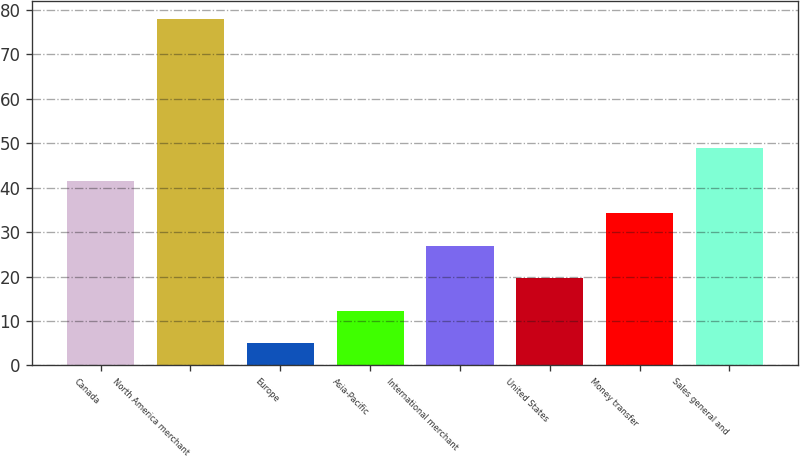Convert chart to OTSL. <chart><loc_0><loc_0><loc_500><loc_500><bar_chart><fcel>Canada<fcel>North America merchant<fcel>Europe<fcel>Asia-Pacific<fcel>International merchant<fcel>United States<fcel>Money transfer<fcel>Sales general and<nl><fcel>41.5<fcel>78<fcel>5<fcel>12.3<fcel>26.9<fcel>19.6<fcel>34.2<fcel>48.8<nl></chart> 